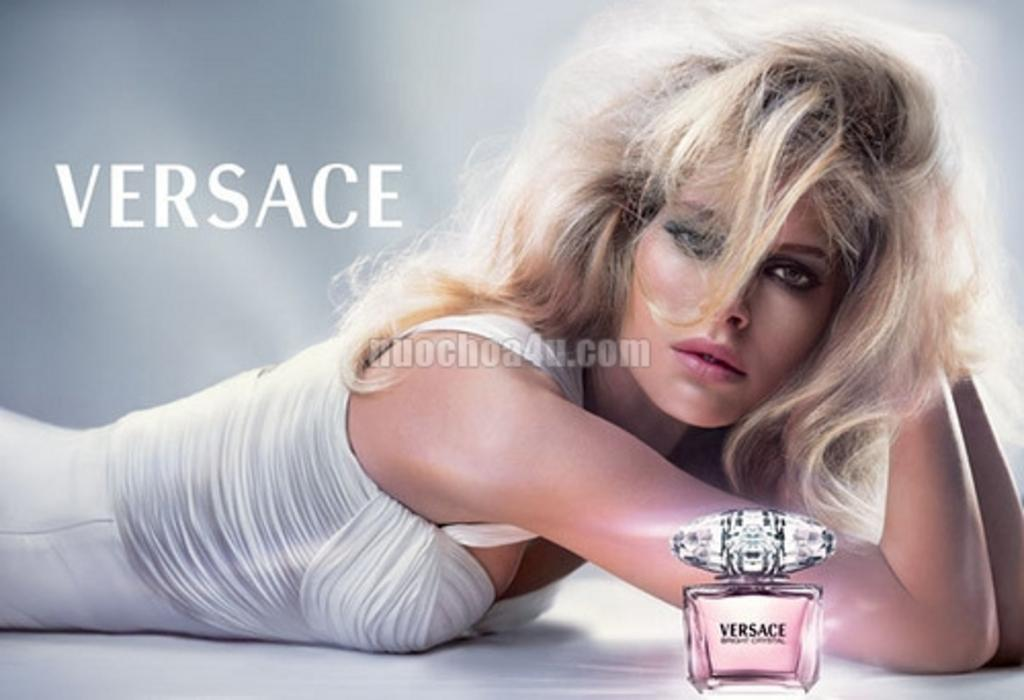Provide a one-sentence caption for the provided image. A Versace perfum ad with a blonde model lying beside the bottle. 